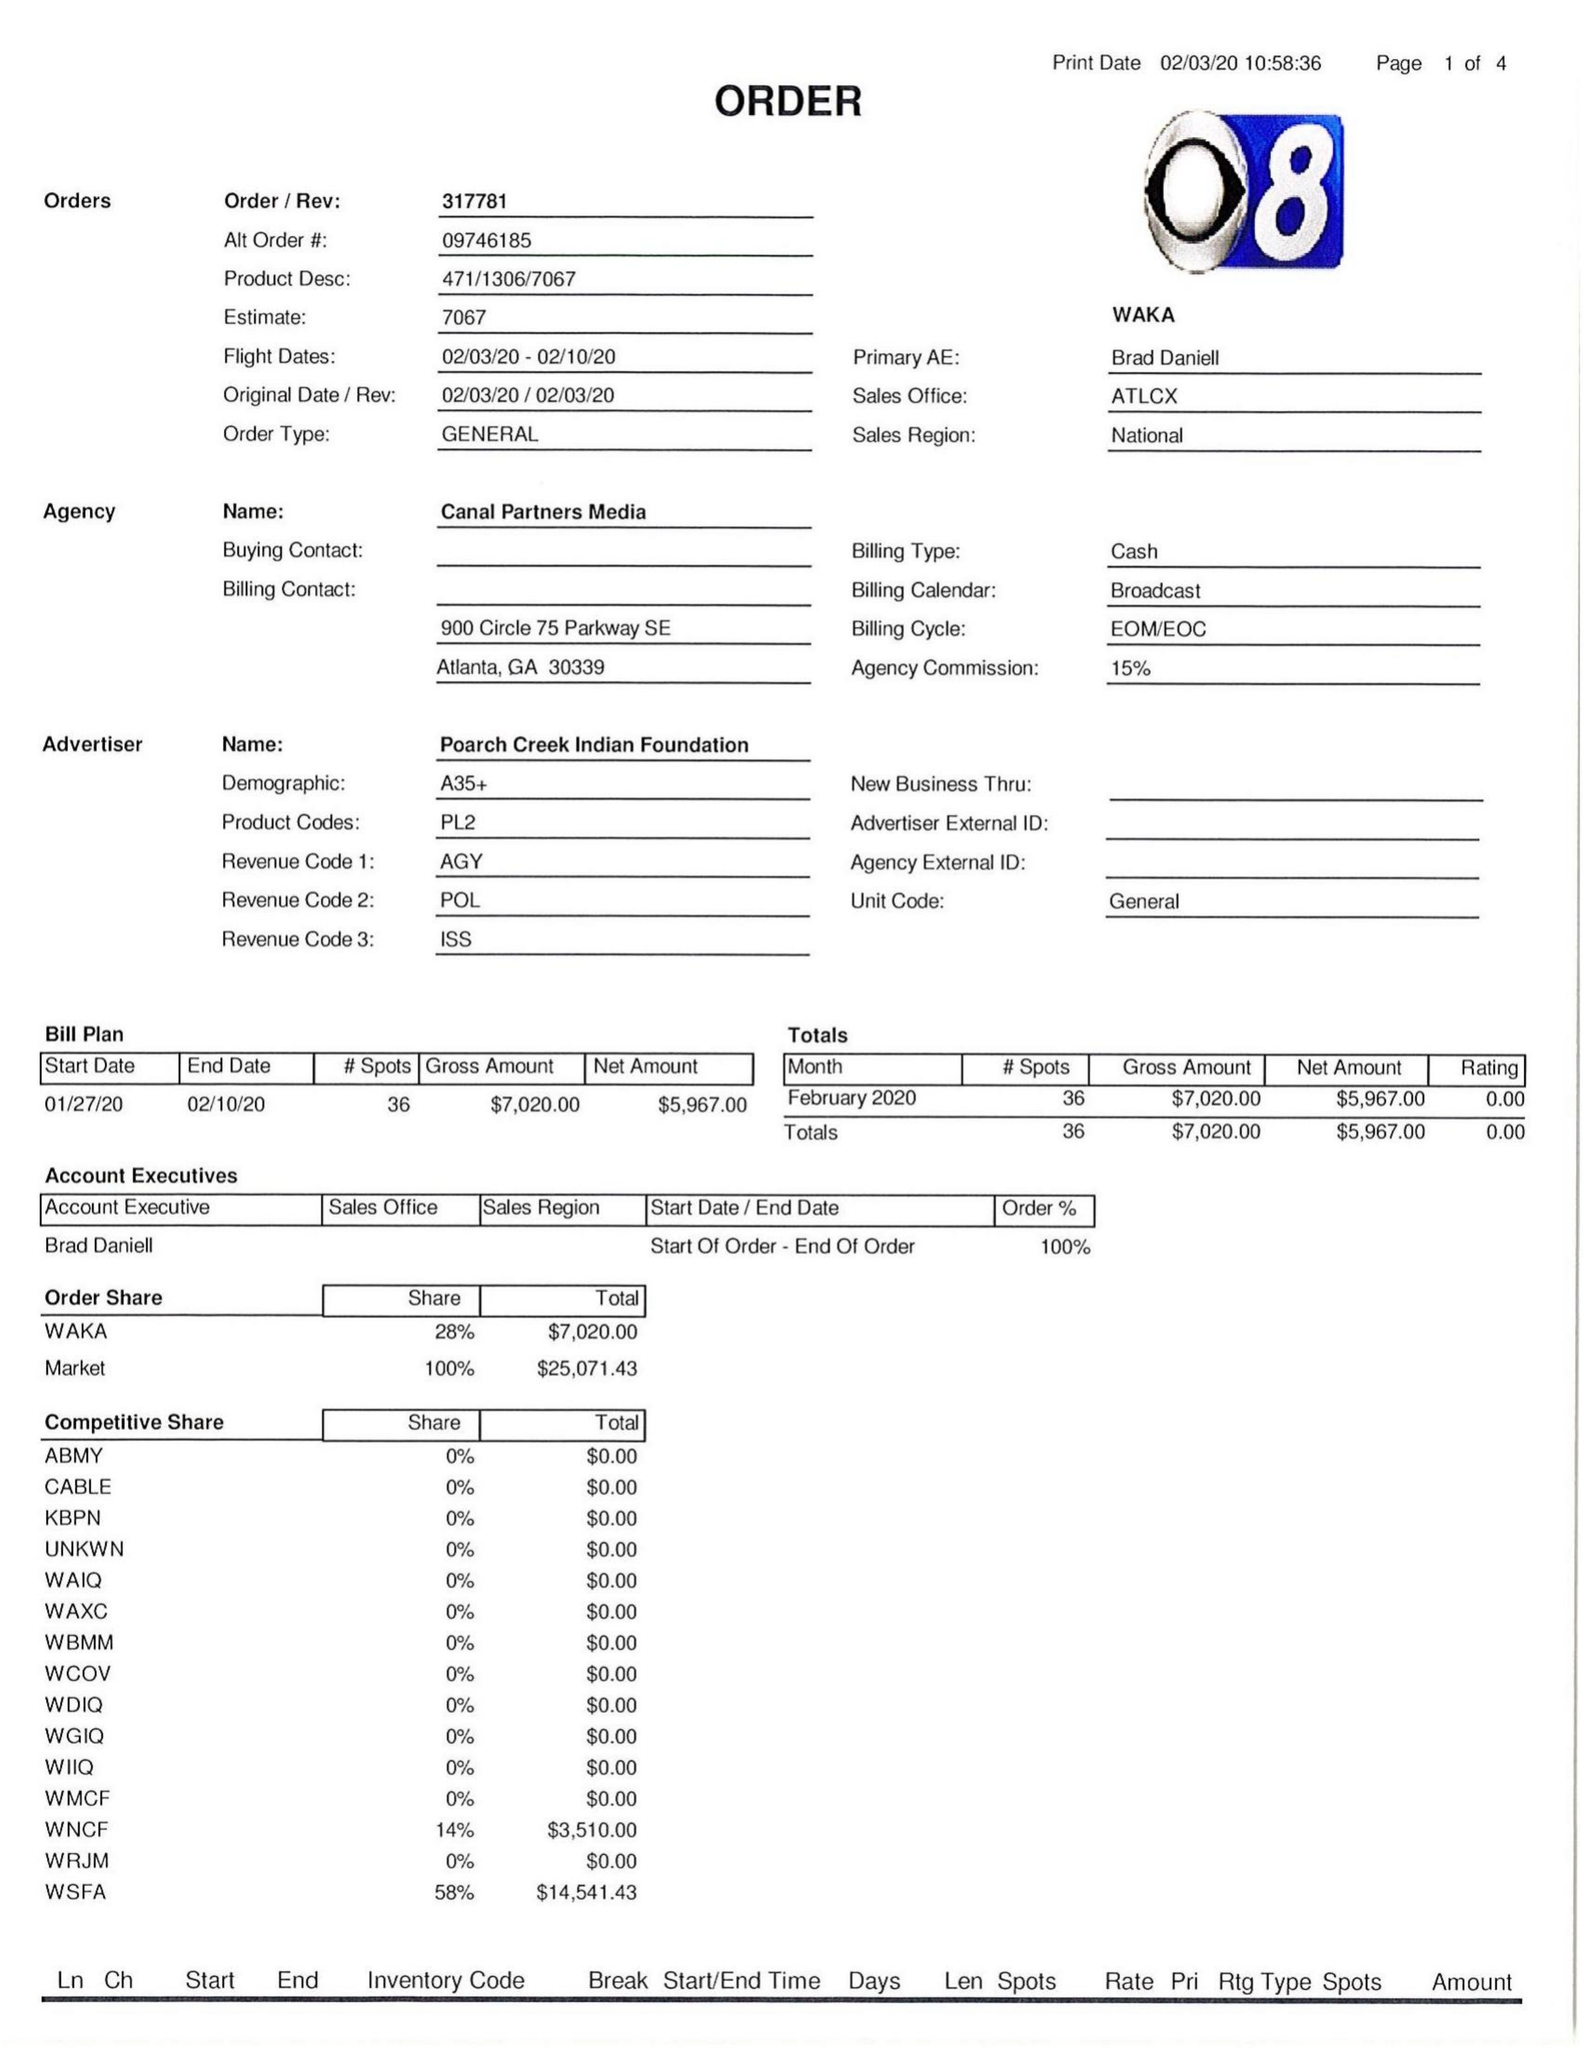What is the value for the gross_amount?
Answer the question using a single word or phrase. 7020.00 